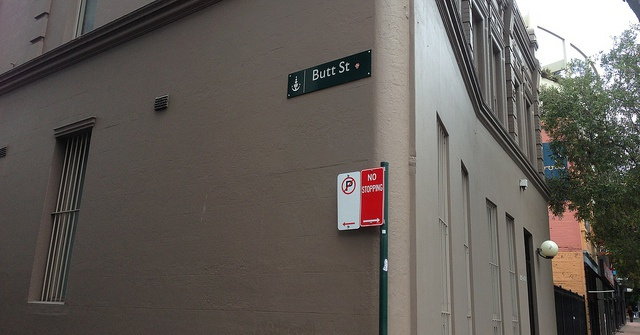Describe the objects in this image and their specific colors. I can see various objects in this image with different colors. 